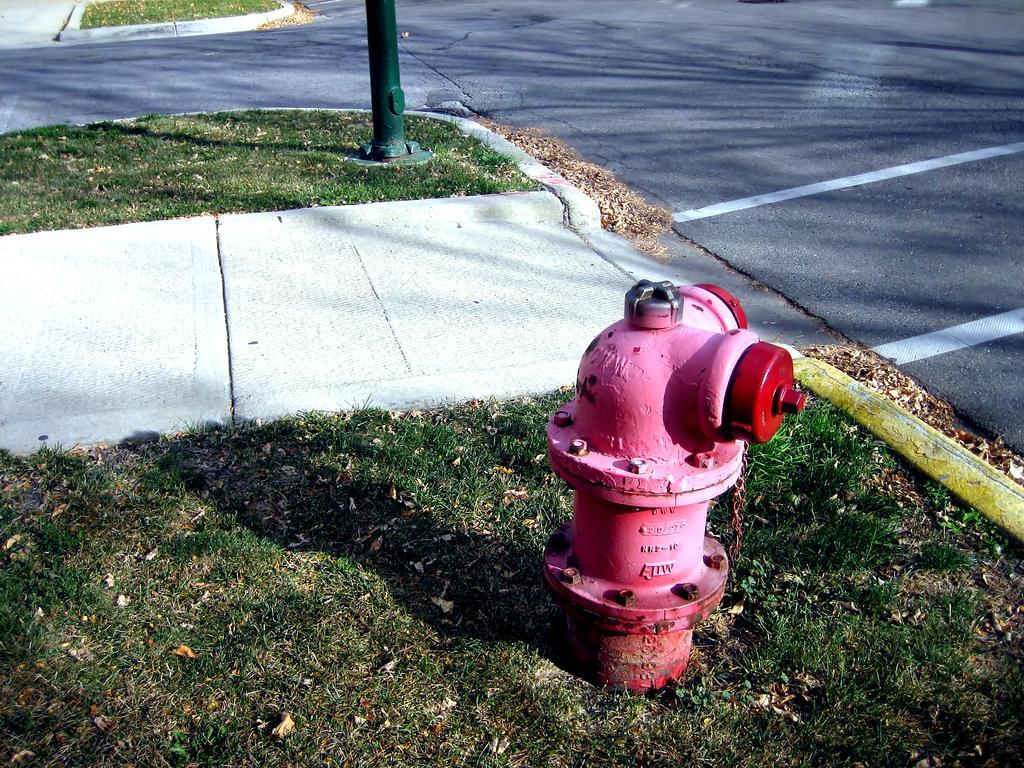Can you describe this image briefly? There is a red color fire hydrant on a greenery ground and there is a green color pole in the background. 